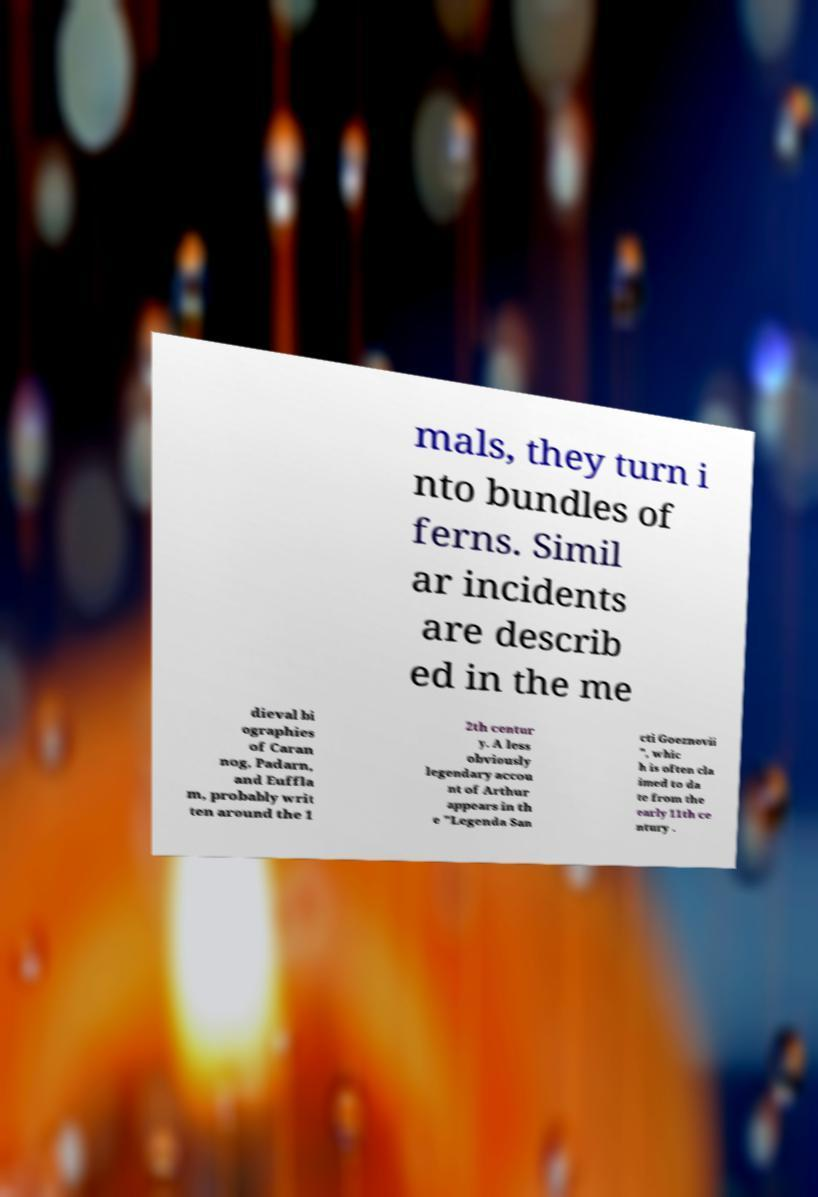There's text embedded in this image that I need extracted. Can you transcribe it verbatim? mals, they turn i nto bundles of ferns. Simil ar incidents are describ ed in the me dieval bi ographies of Caran nog, Padarn, and Euffla m, probably writ ten around the 1 2th centur y. A less obviously legendary accou nt of Arthur appears in th e "Legenda San cti Goeznovii ", whic h is often cla imed to da te from the early 11th ce ntury . 